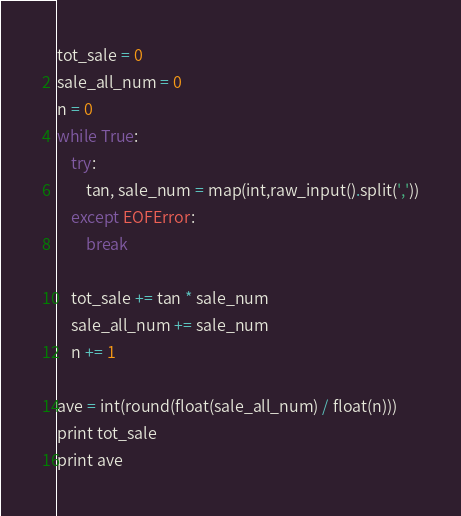Convert code to text. <code><loc_0><loc_0><loc_500><loc_500><_Python_>tot_sale = 0
sale_all_num = 0
n = 0
while True:
    try:
        tan, sale_num = map(int,raw_input().split(','))
    except EOFError:
        break

    tot_sale += tan * sale_num
    sale_all_num += sale_num
    n += 1
    
ave = int(round(float(sale_all_num) / float(n)))
print tot_sale
print ave</code> 